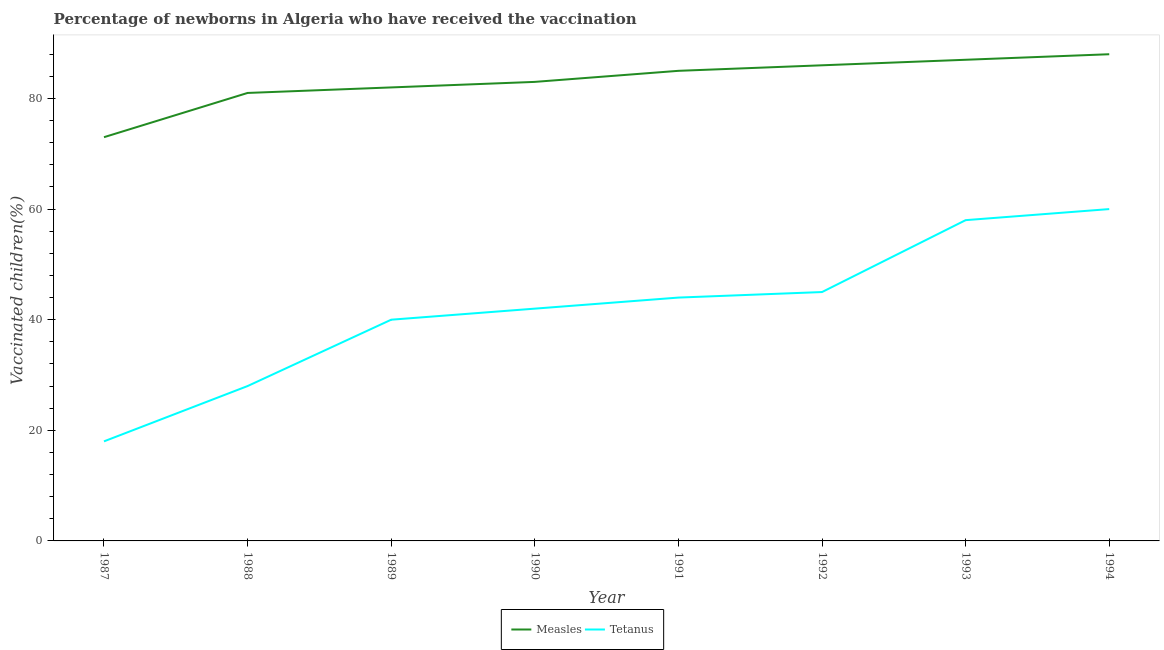Does the line corresponding to percentage of newborns who received vaccination for measles intersect with the line corresponding to percentage of newborns who received vaccination for tetanus?
Your answer should be very brief. No. What is the percentage of newborns who received vaccination for tetanus in 1994?
Keep it short and to the point. 60. Across all years, what is the maximum percentage of newborns who received vaccination for measles?
Offer a very short reply. 88. Across all years, what is the minimum percentage of newborns who received vaccination for tetanus?
Your response must be concise. 18. What is the total percentage of newborns who received vaccination for measles in the graph?
Your answer should be compact. 665. What is the difference between the percentage of newborns who received vaccination for tetanus in 1987 and that in 1989?
Provide a short and direct response. -22. What is the difference between the percentage of newborns who received vaccination for measles in 1988 and the percentage of newborns who received vaccination for tetanus in 1992?
Your response must be concise. 36. What is the average percentage of newborns who received vaccination for measles per year?
Make the answer very short. 83.12. In the year 1988, what is the difference between the percentage of newborns who received vaccination for tetanus and percentage of newborns who received vaccination for measles?
Your response must be concise. -53. What is the ratio of the percentage of newborns who received vaccination for tetanus in 1987 to that in 1993?
Your answer should be very brief. 0.31. What is the difference between the highest and the lowest percentage of newborns who received vaccination for tetanus?
Offer a very short reply. 42. Is the percentage of newborns who received vaccination for measles strictly greater than the percentage of newborns who received vaccination for tetanus over the years?
Provide a succinct answer. Yes. Is the percentage of newborns who received vaccination for tetanus strictly less than the percentage of newborns who received vaccination for measles over the years?
Your answer should be compact. Yes. How many lines are there?
Make the answer very short. 2. What is the difference between two consecutive major ticks on the Y-axis?
Make the answer very short. 20. Are the values on the major ticks of Y-axis written in scientific E-notation?
Your response must be concise. No. How many legend labels are there?
Provide a short and direct response. 2. How are the legend labels stacked?
Your answer should be very brief. Horizontal. What is the title of the graph?
Your response must be concise. Percentage of newborns in Algeria who have received the vaccination. What is the label or title of the X-axis?
Keep it short and to the point. Year. What is the label or title of the Y-axis?
Make the answer very short. Vaccinated children(%)
. What is the Vaccinated children(%)
 of Measles in 1988?
Provide a succinct answer. 81. What is the Vaccinated children(%)
 in Tetanus in 1989?
Provide a short and direct response. 40. What is the Vaccinated children(%)
 in Measles in 1990?
Provide a succinct answer. 83. What is the Vaccinated children(%)
 in Measles in 1991?
Your answer should be very brief. 85. What is the Vaccinated children(%)
 in Measles in 1993?
Your answer should be compact. 87. What is the Vaccinated children(%)
 of Tetanus in 1994?
Offer a very short reply. 60. Across all years, what is the maximum Vaccinated children(%)
 in Measles?
Ensure brevity in your answer.  88. Across all years, what is the maximum Vaccinated children(%)
 in Tetanus?
Your answer should be very brief. 60. Across all years, what is the minimum Vaccinated children(%)
 in Measles?
Offer a very short reply. 73. Across all years, what is the minimum Vaccinated children(%)
 in Tetanus?
Provide a succinct answer. 18. What is the total Vaccinated children(%)
 of Measles in the graph?
Provide a succinct answer. 665. What is the total Vaccinated children(%)
 in Tetanus in the graph?
Keep it short and to the point. 335. What is the difference between the Vaccinated children(%)
 in Tetanus in 1987 and that in 1988?
Offer a terse response. -10. What is the difference between the Vaccinated children(%)
 of Tetanus in 1987 and that in 1989?
Make the answer very short. -22. What is the difference between the Vaccinated children(%)
 in Measles in 1987 and that in 1991?
Your answer should be compact. -12. What is the difference between the Vaccinated children(%)
 of Tetanus in 1987 and that in 1992?
Ensure brevity in your answer.  -27. What is the difference between the Vaccinated children(%)
 of Measles in 1987 and that in 1993?
Provide a short and direct response. -14. What is the difference between the Vaccinated children(%)
 in Tetanus in 1987 and that in 1993?
Your response must be concise. -40. What is the difference between the Vaccinated children(%)
 in Measles in 1987 and that in 1994?
Ensure brevity in your answer.  -15. What is the difference between the Vaccinated children(%)
 of Tetanus in 1987 and that in 1994?
Make the answer very short. -42. What is the difference between the Vaccinated children(%)
 of Measles in 1988 and that in 1990?
Give a very brief answer. -2. What is the difference between the Vaccinated children(%)
 in Tetanus in 1988 and that in 1990?
Ensure brevity in your answer.  -14. What is the difference between the Vaccinated children(%)
 in Tetanus in 1988 and that in 1991?
Give a very brief answer. -16. What is the difference between the Vaccinated children(%)
 in Tetanus in 1988 and that in 1992?
Your answer should be very brief. -17. What is the difference between the Vaccinated children(%)
 in Tetanus in 1988 and that in 1994?
Make the answer very short. -32. What is the difference between the Vaccinated children(%)
 of Measles in 1989 and that in 1990?
Your response must be concise. -1. What is the difference between the Vaccinated children(%)
 of Tetanus in 1989 and that in 1990?
Keep it short and to the point. -2. What is the difference between the Vaccinated children(%)
 in Tetanus in 1989 and that in 1991?
Ensure brevity in your answer.  -4. What is the difference between the Vaccinated children(%)
 of Tetanus in 1989 and that in 1992?
Your answer should be compact. -5. What is the difference between the Vaccinated children(%)
 in Tetanus in 1989 and that in 1993?
Make the answer very short. -18. What is the difference between the Vaccinated children(%)
 in Tetanus in 1989 and that in 1994?
Your response must be concise. -20. What is the difference between the Vaccinated children(%)
 of Measles in 1990 and that in 1991?
Your answer should be very brief. -2. What is the difference between the Vaccinated children(%)
 of Measles in 1990 and that in 1994?
Provide a succinct answer. -5. What is the difference between the Vaccinated children(%)
 in Tetanus in 1990 and that in 1994?
Give a very brief answer. -18. What is the difference between the Vaccinated children(%)
 in Measles in 1991 and that in 1992?
Your response must be concise. -1. What is the difference between the Vaccinated children(%)
 in Tetanus in 1991 and that in 1992?
Ensure brevity in your answer.  -1. What is the difference between the Vaccinated children(%)
 of Measles in 1991 and that in 1994?
Provide a succinct answer. -3. What is the difference between the Vaccinated children(%)
 in Tetanus in 1991 and that in 1994?
Provide a succinct answer. -16. What is the difference between the Vaccinated children(%)
 in Measles in 1992 and that in 1993?
Your answer should be compact. -1. What is the difference between the Vaccinated children(%)
 in Tetanus in 1992 and that in 1993?
Your answer should be very brief. -13. What is the difference between the Vaccinated children(%)
 in Measles in 1992 and that in 1994?
Provide a short and direct response. -2. What is the difference between the Vaccinated children(%)
 in Measles in 1993 and that in 1994?
Ensure brevity in your answer.  -1. What is the difference between the Vaccinated children(%)
 of Measles in 1987 and the Vaccinated children(%)
 of Tetanus in 1988?
Ensure brevity in your answer.  45. What is the difference between the Vaccinated children(%)
 in Measles in 1987 and the Vaccinated children(%)
 in Tetanus in 1990?
Make the answer very short. 31. What is the difference between the Vaccinated children(%)
 in Measles in 1987 and the Vaccinated children(%)
 in Tetanus in 1991?
Your response must be concise. 29. What is the difference between the Vaccinated children(%)
 in Measles in 1987 and the Vaccinated children(%)
 in Tetanus in 1992?
Keep it short and to the point. 28. What is the difference between the Vaccinated children(%)
 of Measles in 1987 and the Vaccinated children(%)
 of Tetanus in 1994?
Offer a very short reply. 13. What is the difference between the Vaccinated children(%)
 in Measles in 1988 and the Vaccinated children(%)
 in Tetanus in 1990?
Make the answer very short. 39. What is the difference between the Vaccinated children(%)
 in Measles in 1988 and the Vaccinated children(%)
 in Tetanus in 1991?
Your response must be concise. 37. What is the difference between the Vaccinated children(%)
 in Measles in 1988 and the Vaccinated children(%)
 in Tetanus in 1994?
Keep it short and to the point. 21. What is the difference between the Vaccinated children(%)
 in Measles in 1989 and the Vaccinated children(%)
 in Tetanus in 1990?
Offer a terse response. 40. What is the difference between the Vaccinated children(%)
 in Measles in 1989 and the Vaccinated children(%)
 in Tetanus in 1993?
Your answer should be very brief. 24. What is the difference between the Vaccinated children(%)
 of Measles in 1990 and the Vaccinated children(%)
 of Tetanus in 1992?
Ensure brevity in your answer.  38. What is the difference between the Vaccinated children(%)
 of Measles in 1992 and the Vaccinated children(%)
 of Tetanus in 1994?
Your answer should be very brief. 26. What is the average Vaccinated children(%)
 in Measles per year?
Offer a terse response. 83.12. What is the average Vaccinated children(%)
 in Tetanus per year?
Provide a succinct answer. 41.88. In the year 1991, what is the difference between the Vaccinated children(%)
 of Measles and Vaccinated children(%)
 of Tetanus?
Your answer should be compact. 41. In the year 1994, what is the difference between the Vaccinated children(%)
 of Measles and Vaccinated children(%)
 of Tetanus?
Provide a succinct answer. 28. What is the ratio of the Vaccinated children(%)
 of Measles in 1987 to that in 1988?
Offer a terse response. 0.9. What is the ratio of the Vaccinated children(%)
 in Tetanus in 1987 to that in 1988?
Your answer should be compact. 0.64. What is the ratio of the Vaccinated children(%)
 in Measles in 1987 to that in 1989?
Offer a terse response. 0.89. What is the ratio of the Vaccinated children(%)
 of Tetanus in 1987 to that in 1989?
Offer a terse response. 0.45. What is the ratio of the Vaccinated children(%)
 of Measles in 1987 to that in 1990?
Your answer should be very brief. 0.88. What is the ratio of the Vaccinated children(%)
 in Tetanus in 1987 to that in 1990?
Ensure brevity in your answer.  0.43. What is the ratio of the Vaccinated children(%)
 in Measles in 1987 to that in 1991?
Give a very brief answer. 0.86. What is the ratio of the Vaccinated children(%)
 in Tetanus in 1987 to that in 1991?
Ensure brevity in your answer.  0.41. What is the ratio of the Vaccinated children(%)
 in Measles in 1987 to that in 1992?
Offer a terse response. 0.85. What is the ratio of the Vaccinated children(%)
 in Tetanus in 1987 to that in 1992?
Your answer should be very brief. 0.4. What is the ratio of the Vaccinated children(%)
 of Measles in 1987 to that in 1993?
Give a very brief answer. 0.84. What is the ratio of the Vaccinated children(%)
 in Tetanus in 1987 to that in 1993?
Your answer should be compact. 0.31. What is the ratio of the Vaccinated children(%)
 in Measles in 1987 to that in 1994?
Provide a succinct answer. 0.83. What is the ratio of the Vaccinated children(%)
 in Measles in 1988 to that in 1990?
Provide a succinct answer. 0.98. What is the ratio of the Vaccinated children(%)
 of Tetanus in 1988 to that in 1990?
Make the answer very short. 0.67. What is the ratio of the Vaccinated children(%)
 of Measles in 1988 to that in 1991?
Your response must be concise. 0.95. What is the ratio of the Vaccinated children(%)
 in Tetanus in 1988 to that in 1991?
Offer a terse response. 0.64. What is the ratio of the Vaccinated children(%)
 of Measles in 1988 to that in 1992?
Keep it short and to the point. 0.94. What is the ratio of the Vaccinated children(%)
 in Tetanus in 1988 to that in 1992?
Your answer should be compact. 0.62. What is the ratio of the Vaccinated children(%)
 in Tetanus in 1988 to that in 1993?
Give a very brief answer. 0.48. What is the ratio of the Vaccinated children(%)
 of Measles in 1988 to that in 1994?
Make the answer very short. 0.92. What is the ratio of the Vaccinated children(%)
 in Tetanus in 1988 to that in 1994?
Your response must be concise. 0.47. What is the ratio of the Vaccinated children(%)
 of Tetanus in 1989 to that in 1990?
Your answer should be compact. 0.95. What is the ratio of the Vaccinated children(%)
 in Measles in 1989 to that in 1991?
Your answer should be very brief. 0.96. What is the ratio of the Vaccinated children(%)
 in Tetanus in 1989 to that in 1991?
Offer a terse response. 0.91. What is the ratio of the Vaccinated children(%)
 in Measles in 1989 to that in 1992?
Provide a succinct answer. 0.95. What is the ratio of the Vaccinated children(%)
 in Tetanus in 1989 to that in 1992?
Your response must be concise. 0.89. What is the ratio of the Vaccinated children(%)
 of Measles in 1989 to that in 1993?
Provide a short and direct response. 0.94. What is the ratio of the Vaccinated children(%)
 of Tetanus in 1989 to that in 1993?
Provide a short and direct response. 0.69. What is the ratio of the Vaccinated children(%)
 of Measles in 1989 to that in 1994?
Keep it short and to the point. 0.93. What is the ratio of the Vaccinated children(%)
 in Measles in 1990 to that in 1991?
Offer a terse response. 0.98. What is the ratio of the Vaccinated children(%)
 of Tetanus in 1990 to that in 1991?
Your answer should be compact. 0.95. What is the ratio of the Vaccinated children(%)
 of Measles in 1990 to that in 1992?
Offer a very short reply. 0.97. What is the ratio of the Vaccinated children(%)
 in Tetanus in 1990 to that in 1992?
Offer a very short reply. 0.93. What is the ratio of the Vaccinated children(%)
 of Measles in 1990 to that in 1993?
Your answer should be compact. 0.95. What is the ratio of the Vaccinated children(%)
 in Tetanus in 1990 to that in 1993?
Give a very brief answer. 0.72. What is the ratio of the Vaccinated children(%)
 of Measles in 1990 to that in 1994?
Make the answer very short. 0.94. What is the ratio of the Vaccinated children(%)
 of Tetanus in 1990 to that in 1994?
Your answer should be very brief. 0.7. What is the ratio of the Vaccinated children(%)
 of Measles in 1991 to that in 1992?
Provide a succinct answer. 0.99. What is the ratio of the Vaccinated children(%)
 in Tetanus in 1991 to that in 1992?
Your answer should be very brief. 0.98. What is the ratio of the Vaccinated children(%)
 of Measles in 1991 to that in 1993?
Your answer should be very brief. 0.98. What is the ratio of the Vaccinated children(%)
 of Tetanus in 1991 to that in 1993?
Keep it short and to the point. 0.76. What is the ratio of the Vaccinated children(%)
 of Measles in 1991 to that in 1994?
Your answer should be very brief. 0.97. What is the ratio of the Vaccinated children(%)
 in Tetanus in 1991 to that in 1994?
Keep it short and to the point. 0.73. What is the ratio of the Vaccinated children(%)
 in Tetanus in 1992 to that in 1993?
Offer a terse response. 0.78. What is the ratio of the Vaccinated children(%)
 in Measles in 1992 to that in 1994?
Provide a short and direct response. 0.98. What is the ratio of the Vaccinated children(%)
 of Tetanus in 1992 to that in 1994?
Make the answer very short. 0.75. What is the ratio of the Vaccinated children(%)
 of Measles in 1993 to that in 1994?
Your answer should be compact. 0.99. What is the ratio of the Vaccinated children(%)
 in Tetanus in 1993 to that in 1994?
Offer a very short reply. 0.97. 